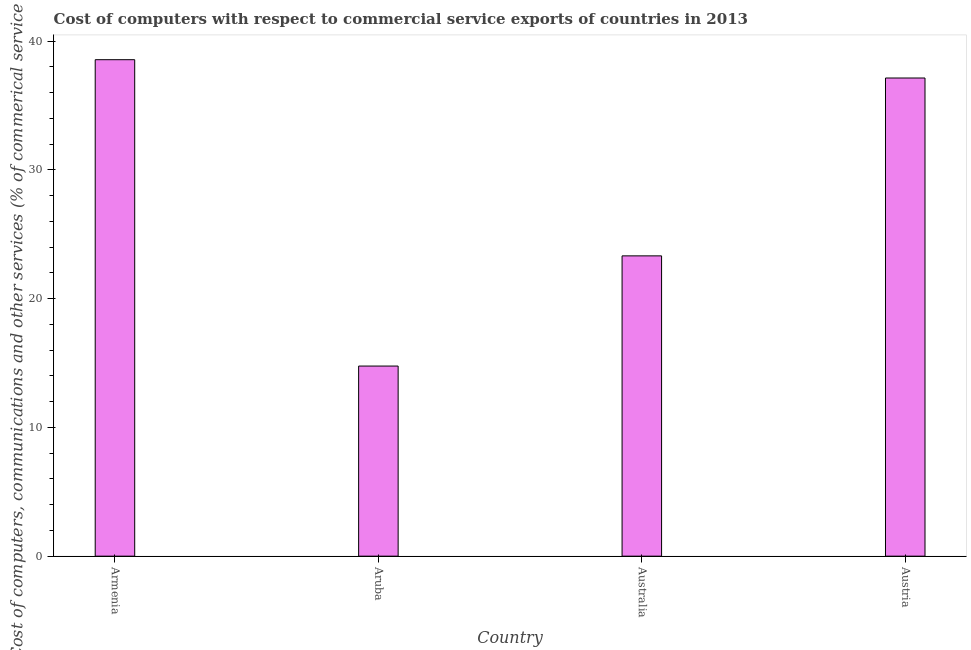What is the title of the graph?
Keep it short and to the point. Cost of computers with respect to commercial service exports of countries in 2013. What is the label or title of the X-axis?
Provide a succinct answer. Country. What is the label or title of the Y-axis?
Give a very brief answer. Cost of computers, communications and other services (% of commerical service exports). What is the cost of communications in Armenia?
Give a very brief answer. 38.55. Across all countries, what is the maximum  computer and other services?
Your answer should be compact. 38.55. Across all countries, what is the minimum  computer and other services?
Your answer should be compact. 14.76. In which country was the cost of communications maximum?
Your answer should be compact. Armenia. In which country was the  computer and other services minimum?
Your answer should be compact. Aruba. What is the sum of the  computer and other services?
Keep it short and to the point. 113.75. What is the difference between the  computer and other services in Aruba and Austria?
Ensure brevity in your answer.  -22.36. What is the average cost of communications per country?
Make the answer very short. 28.44. What is the median  computer and other services?
Your response must be concise. 30.22. In how many countries, is the cost of communications greater than 14 %?
Your response must be concise. 4. What is the ratio of the  computer and other services in Armenia to that in Australia?
Your answer should be compact. 1.65. Is the cost of communications in Aruba less than that in Australia?
Ensure brevity in your answer.  Yes. Is the difference between the  computer and other services in Aruba and Australia greater than the difference between any two countries?
Your response must be concise. No. What is the difference between the highest and the second highest cost of communications?
Offer a very short reply. 1.42. What is the difference between the highest and the lowest cost of communications?
Offer a terse response. 23.79. In how many countries, is the  computer and other services greater than the average  computer and other services taken over all countries?
Give a very brief answer. 2. How many bars are there?
Provide a short and direct response. 4. Are all the bars in the graph horizontal?
Offer a very short reply. No. How many countries are there in the graph?
Ensure brevity in your answer.  4. Are the values on the major ticks of Y-axis written in scientific E-notation?
Make the answer very short. No. What is the Cost of computers, communications and other services (% of commerical service exports) of Armenia?
Your answer should be very brief. 38.55. What is the Cost of computers, communications and other services (% of commerical service exports) of Aruba?
Provide a short and direct response. 14.76. What is the Cost of computers, communications and other services (% of commerical service exports) in Australia?
Provide a succinct answer. 23.32. What is the Cost of computers, communications and other services (% of commerical service exports) of Austria?
Give a very brief answer. 37.13. What is the difference between the Cost of computers, communications and other services (% of commerical service exports) in Armenia and Aruba?
Ensure brevity in your answer.  23.79. What is the difference between the Cost of computers, communications and other services (% of commerical service exports) in Armenia and Australia?
Provide a succinct answer. 15.23. What is the difference between the Cost of computers, communications and other services (% of commerical service exports) in Armenia and Austria?
Offer a terse response. 1.42. What is the difference between the Cost of computers, communications and other services (% of commerical service exports) in Aruba and Australia?
Your answer should be compact. -8.56. What is the difference between the Cost of computers, communications and other services (% of commerical service exports) in Aruba and Austria?
Your answer should be compact. -22.37. What is the difference between the Cost of computers, communications and other services (% of commerical service exports) in Australia and Austria?
Make the answer very short. -13.81. What is the ratio of the Cost of computers, communications and other services (% of commerical service exports) in Armenia to that in Aruba?
Your response must be concise. 2.61. What is the ratio of the Cost of computers, communications and other services (% of commerical service exports) in Armenia to that in Australia?
Give a very brief answer. 1.65. What is the ratio of the Cost of computers, communications and other services (% of commerical service exports) in Armenia to that in Austria?
Keep it short and to the point. 1.04. What is the ratio of the Cost of computers, communications and other services (% of commerical service exports) in Aruba to that in Australia?
Offer a terse response. 0.63. What is the ratio of the Cost of computers, communications and other services (% of commerical service exports) in Aruba to that in Austria?
Make the answer very short. 0.4. What is the ratio of the Cost of computers, communications and other services (% of commerical service exports) in Australia to that in Austria?
Offer a terse response. 0.63. 